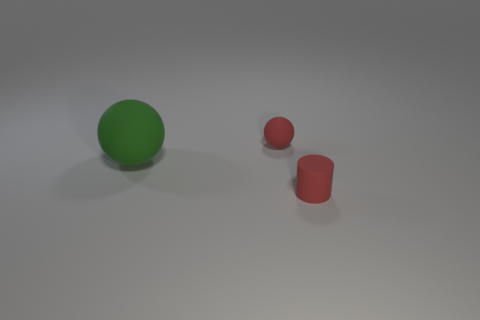How many other objects are the same material as the green sphere?
Give a very brief answer. 2. What is the material of the big green thing?
Your answer should be very brief. Rubber. How big is the rubber object behind the large matte sphere?
Provide a short and direct response. Small. What number of rubber cylinders are behind the tiny matte object that is in front of the big ball?
Keep it short and to the point. 0. There is a red object to the left of the small rubber cylinder; is it the same shape as the red object that is on the right side of the small red rubber sphere?
Ensure brevity in your answer.  No. What number of tiny red objects are both behind the matte cylinder and on the right side of the red matte ball?
Keep it short and to the point. 0. Are there any tiny rubber cylinders that have the same color as the tiny matte ball?
Give a very brief answer. Yes. What is the shape of the rubber object that is the same size as the rubber cylinder?
Keep it short and to the point. Sphere. There is a green rubber sphere; are there any small matte things to the left of it?
Provide a succinct answer. No. What number of red matte cylinders are the same size as the green object?
Make the answer very short. 0. 